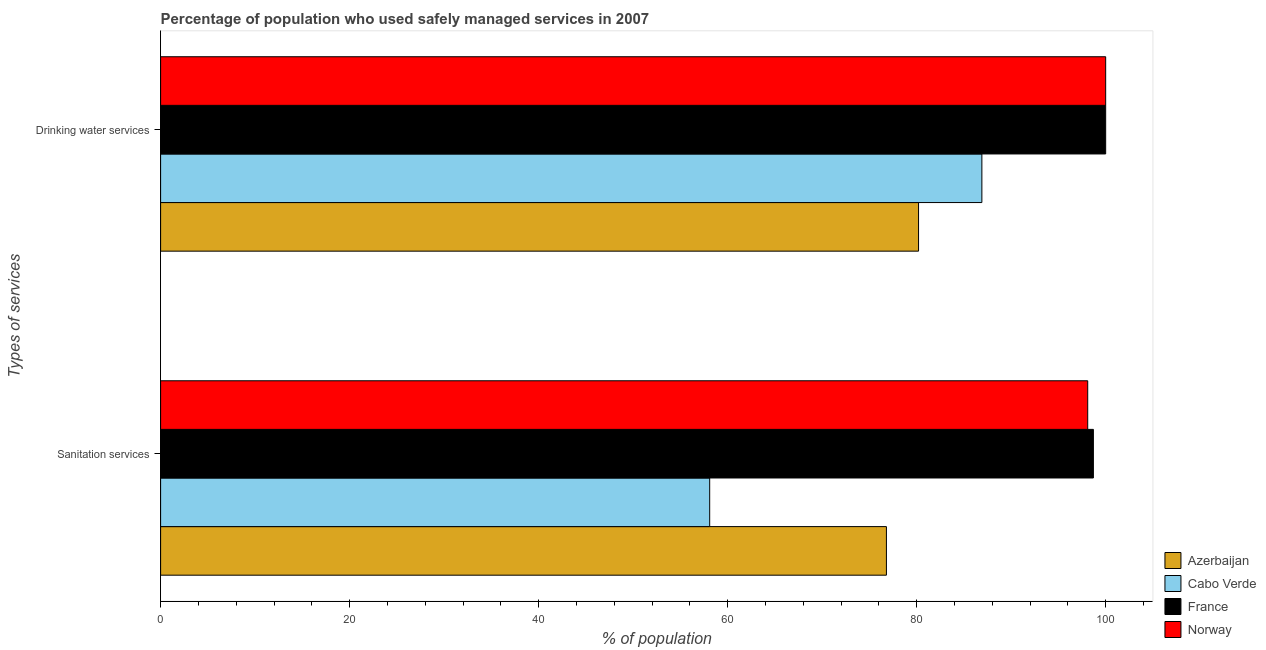How many different coloured bars are there?
Your answer should be compact. 4. How many groups of bars are there?
Offer a very short reply. 2. Are the number of bars per tick equal to the number of legend labels?
Give a very brief answer. Yes. How many bars are there on the 2nd tick from the top?
Offer a very short reply. 4. What is the label of the 2nd group of bars from the top?
Your answer should be very brief. Sanitation services. What is the percentage of population who used drinking water services in Azerbaijan?
Offer a terse response. 80.2. Across all countries, what is the maximum percentage of population who used drinking water services?
Provide a succinct answer. 100. Across all countries, what is the minimum percentage of population who used drinking water services?
Ensure brevity in your answer.  80.2. In which country was the percentage of population who used drinking water services maximum?
Make the answer very short. France. In which country was the percentage of population who used sanitation services minimum?
Provide a short and direct response. Cabo Verde. What is the total percentage of population who used sanitation services in the graph?
Make the answer very short. 331.7. What is the difference between the percentage of population who used drinking water services in Cabo Verde and that in Norway?
Your response must be concise. -13.1. What is the difference between the percentage of population who used drinking water services in Norway and the percentage of population who used sanitation services in Cabo Verde?
Provide a succinct answer. 41.9. What is the average percentage of population who used drinking water services per country?
Your answer should be very brief. 91.78. What is the difference between the percentage of population who used sanitation services and percentage of population who used drinking water services in Azerbaijan?
Keep it short and to the point. -3.4. What is the ratio of the percentage of population who used drinking water services in France to that in Azerbaijan?
Ensure brevity in your answer.  1.25. Is the percentage of population who used drinking water services in Cabo Verde less than that in Norway?
Your response must be concise. Yes. In how many countries, is the percentage of population who used sanitation services greater than the average percentage of population who used sanitation services taken over all countries?
Ensure brevity in your answer.  2. What does the 2nd bar from the top in Sanitation services represents?
Provide a short and direct response. France. What does the 3rd bar from the bottom in Drinking water services represents?
Your answer should be compact. France. How many countries are there in the graph?
Keep it short and to the point. 4. Are the values on the major ticks of X-axis written in scientific E-notation?
Provide a succinct answer. No. Does the graph contain any zero values?
Provide a succinct answer. No. Does the graph contain grids?
Make the answer very short. No. Where does the legend appear in the graph?
Offer a very short reply. Bottom right. How are the legend labels stacked?
Provide a succinct answer. Vertical. What is the title of the graph?
Keep it short and to the point. Percentage of population who used safely managed services in 2007. What is the label or title of the X-axis?
Offer a terse response. % of population. What is the label or title of the Y-axis?
Offer a terse response. Types of services. What is the % of population in Azerbaijan in Sanitation services?
Provide a short and direct response. 76.8. What is the % of population of Cabo Verde in Sanitation services?
Provide a succinct answer. 58.1. What is the % of population in France in Sanitation services?
Give a very brief answer. 98.7. What is the % of population in Norway in Sanitation services?
Ensure brevity in your answer.  98.1. What is the % of population in Azerbaijan in Drinking water services?
Offer a terse response. 80.2. What is the % of population in Cabo Verde in Drinking water services?
Make the answer very short. 86.9. What is the % of population in France in Drinking water services?
Provide a short and direct response. 100. What is the % of population in Norway in Drinking water services?
Your answer should be very brief. 100. Across all Types of services, what is the maximum % of population of Azerbaijan?
Provide a short and direct response. 80.2. Across all Types of services, what is the maximum % of population in Cabo Verde?
Offer a very short reply. 86.9. Across all Types of services, what is the maximum % of population in France?
Provide a short and direct response. 100. Across all Types of services, what is the minimum % of population in Azerbaijan?
Provide a short and direct response. 76.8. Across all Types of services, what is the minimum % of population in Cabo Verde?
Your response must be concise. 58.1. Across all Types of services, what is the minimum % of population of France?
Ensure brevity in your answer.  98.7. Across all Types of services, what is the minimum % of population in Norway?
Make the answer very short. 98.1. What is the total % of population of Azerbaijan in the graph?
Ensure brevity in your answer.  157. What is the total % of population in Cabo Verde in the graph?
Ensure brevity in your answer.  145. What is the total % of population in France in the graph?
Provide a short and direct response. 198.7. What is the total % of population of Norway in the graph?
Ensure brevity in your answer.  198.1. What is the difference between the % of population of Cabo Verde in Sanitation services and that in Drinking water services?
Your response must be concise. -28.8. What is the difference between the % of population of France in Sanitation services and that in Drinking water services?
Ensure brevity in your answer.  -1.3. What is the difference between the % of population in Azerbaijan in Sanitation services and the % of population in France in Drinking water services?
Provide a short and direct response. -23.2. What is the difference between the % of population of Azerbaijan in Sanitation services and the % of population of Norway in Drinking water services?
Make the answer very short. -23.2. What is the difference between the % of population in Cabo Verde in Sanitation services and the % of population in France in Drinking water services?
Keep it short and to the point. -41.9. What is the difference between the % of population in Cabo Verde in Sanitation services and the % of population in Norway in Drinking water services?
Keep it short and to the point. -41.9. What is the difference between the % of population of France in Sanitation services and the % of population of Norway in Drinking water services?
Keep it short and to the point. -1.3. What is the average % of population of Azerbaijan per Types of services?
Make the answer very short. 78.5. What is the average % of population of Cabo Verde per Types of services?
Offer a very short reply. 72.5. What is the average % of population of France per Types of services?
Your answer should be very brief. 99.35. What is the average % of population in Norway per Types of services?
Provide a short and direct response. 99.05. What is the difference between the % of population of Azerbaijan and % of population of Cabo Verde in Sanitation services?
Your answer should be very brief. 18.7. What is the difference between the % of population in Azerbaijan and % of population in France in Sanitation services?
Provide a short and direct response. -21.9. What is the difference between the % of population of Azerbaijan and % of population of Norway in Sanitation services?
Offer a terse response. -21.3. What is the difference between the % of population in Cabo Verde and % of population in France in Sanitation services?
Offer a terse response. -40.6. What is the difference between the % of population in France and % of population in Norway in Sanitation services?
Keep it short and to the point. 0.6. What is the difference between the % of population of Azerbaijan and % of population of Cabo Verde in Drinking water services?
Offer a very short reply. -6.7. What is the difference between the % of population in Azerbaijan and % of population in France in Drinking water services?
Offer a terse response. -19.8. What is the difference between the % of population in Azerbaijan and % of population in Norway in Drinking water services?
Your answer should be compact. -19.8. What is the ratio of the % of population in Azerbaijan in Sanitation services to that in Drinking water services?
Offer a terse response. 0.96. What is the ratio of the % of population in Cabo Verde in Sanitation services to that in Drinking water services?
Ensure brevity in your answer.  0.67. What is the difference between the highest and the second highest % of population in Azerbaijan?
Your answer should be compact. 3.4. What is the difference between the highest and the second highest % of population in Cabo Verde?
Your response must be concise. 28.8. What is the difference between the highest and the second highest % of population in France?
Your response must be concise. 1.3. What is the difference between the highest and the second highest % of population of Norway?
Offer a very short reply. 1.9. What is the difference between the highest and the lowest % of population of Cabo Verde?
Give a very brief answer. 28.8. What is the difference between the highest and the lowest % of population in France?
Keep it short and to the point. 1.3. 